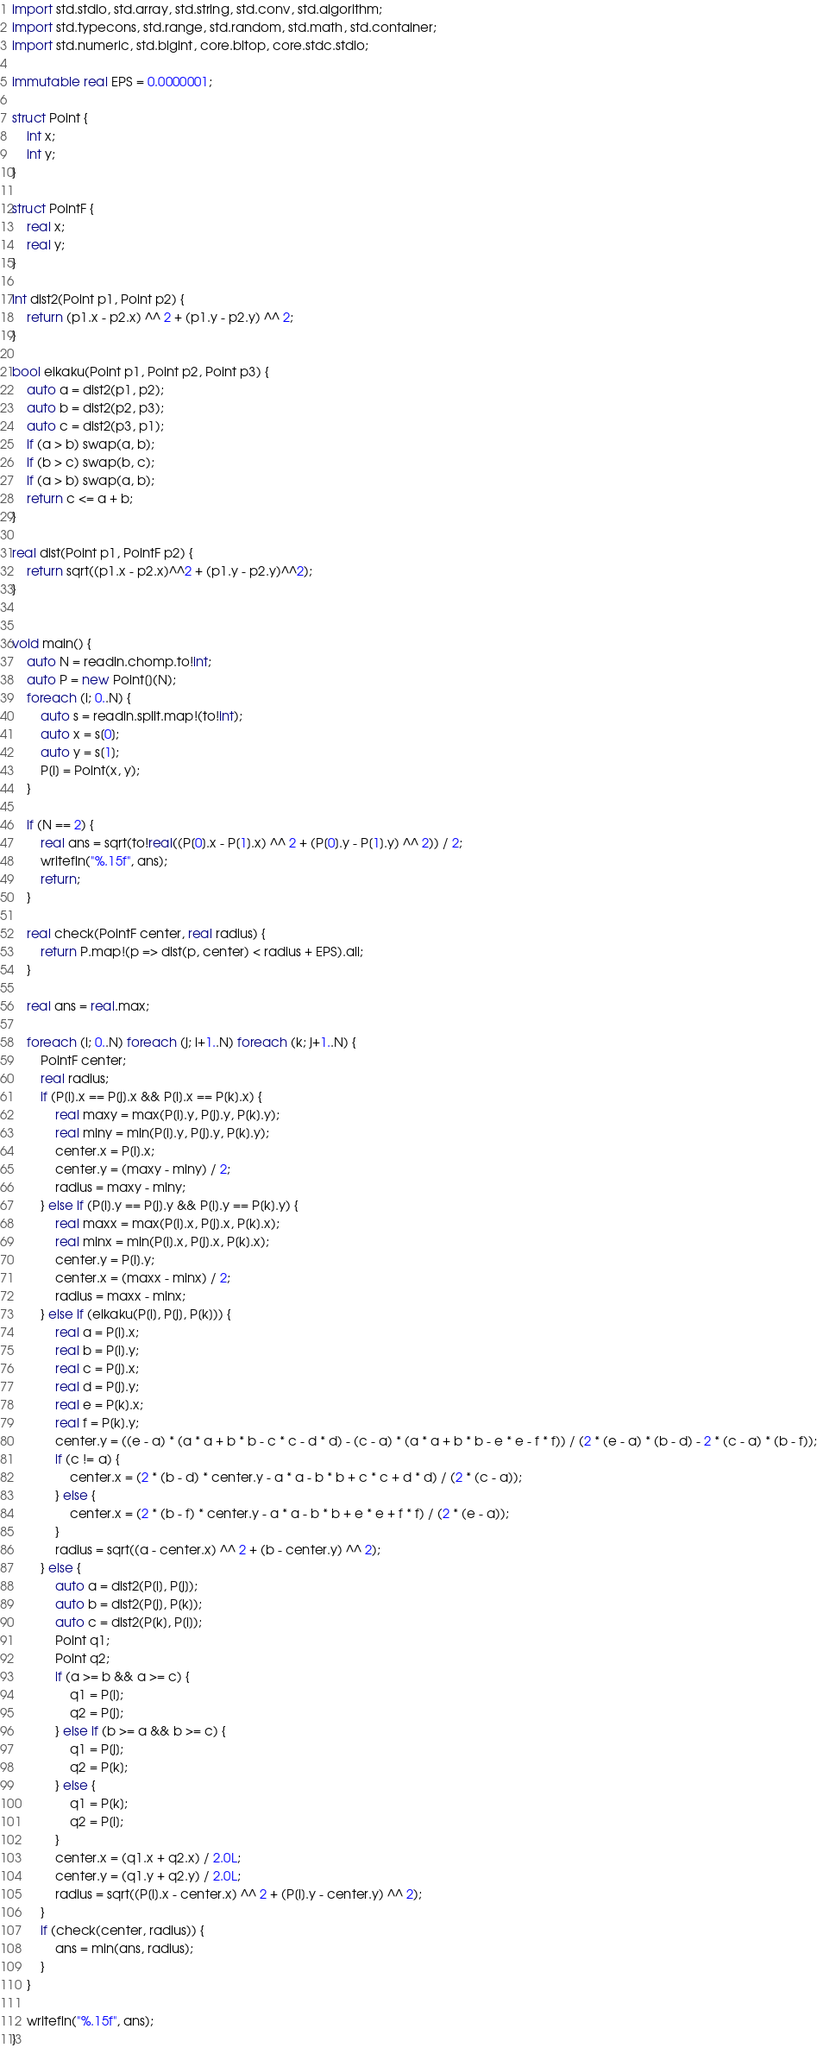<code> <loc_0><loc_0><loc_500><loc_500><_D_>import std.stdio, std.array, std.string, std.conv, std.algorithm;
import std.typecons, std.range, std.random, std.math, std.container;
import std.numeric, std.bigint, core.bitop, core.stdc.stdio;

immutable real EPS = 0.0000001;

struct Point {
    int x;
    int y;
}

struct PointF {
    real x;
    real y;
}

int dist2(Point p1, Point p2) {
    return (p1.x - p2.x) ^^ 2 + (p1.y - p2.y) ^^ 2;
}

bool eikaku(Point p1, Point p2, Point p3) {
    auto a = dist2(p1, p2);
    auto b = dist2(p2, p3);
    auto c = dist2(p3, p1);
    if (a > b) swap(a, b);
    if (b > c) swap(b, c);
    if (a > b) swap(a, b);
    return c <= a + b;
}

real dist(Point p1, PointF p2) {
    return sqrt((p1.x - p2.x)^^2 + (p1.y - p2.y)^^2);
}


void main() {
    auto N = readln.chomp.to!int;
    auto P = new Point[](N);
    foreach (i; 0..N) {
        auto s = readln.split.map!(to!int);
        auto x = s[0];
        auto y = s[1];
        P[i] = Point(x, y);
    }

    if (N == 2) {
        real ans = sqrt(to!real((P[0].x - P[1].x) ^^ 2 + (P[0].y - P[1].y) ^^ 2)) / 2;
        writefln("%.15f", ans);
        return;
    }

    real check(PointF center, real radius) {
        return P.map!(p => dist(p, center) < radius + EPS).all;
    }

    real ans = real.max;

    foreach (i; 0..N) foreach (j; i+1..N) foreach (k; j+1..N) {
        PointF center;
        real radius;
        if (P[i].x == P[j].x && P[i].x == P[k].x) {
            real maxy = max(P[i].y, P[j].y, P[k].y);
            real miny = min(P[i].y, P[j].y, P[k].y);
            center.x = P[i].x;
            center.y = (maxy - miny) / 2;
            radius = maxy - miny;
        } else if (P[i].y == P[j].y && P[i].y == P[k].y) {
            real maxx = max(P[i].x, P[j].x, P[k].x);
            real minx = min(P[i].x, P[j].x, P[k].x);
            center.y = P[i].y;
            center.x = (maxx - minx) / 2;
            radius = maxx - minx;
        } else if (eikaku(P[i], P[j], P[k])) {
            real a = P[i].x;
            real b = P[i].y;
            real c = P[j].x;
            real d = P[j].y;
            real e = P[k].x;
            real f = P[k].y;
            center.y = ((e - a) * (a * a + b * b - c * c - d * d) - (c - a) * (a * a + b * b - e * e - f * f)) / (2 * (e - a) * (b - d) - 2 * (c - a) * (b - f));
            if (c != a) {
                center.x = (2 * (b - d) * center.y - a * a - b * b + c * c + d * d) / (2 * (c - a));
            } else {
                center.x = (2 * (b - f) * center.y - a * a - b * b + e * e + f * f) / (2 * (e - a));
            }
            radius = sqrt((a - center.x) ^^ 2 + (b - center.y) ^^ 2);
        } else {
            auto a = dist2(P[i], P[j]);
            auto b = dist2(P[j], P[k]);
            auto c = dist2(P[k], P[i]);
            Point q1;
            Point q2;
            if (a >= b && a >= c) {
                q1 = P[i];
                q2 = P[j];
            } else if (b >= a && b >= c) {
                q1 = P[j];
                q2 = P[k];
            } else {
                q1 = P[k];
                q2 = P[i];
            }
            center.x = (q1.x + q2.x) / 2.0L;
            center.y = (q1.y + q2.y) / 2.0L;
            radius = sqrt((P[i].x - center.x) ^^ 2 + (P[i].y - center.y) ^^ 2);
        }
        if (check(center, radius)) {
            ans = min(ans, radius);
        }
    }

    writefln("%.15f", ans);
}</code> 